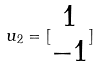<formula> <loc_0><loc_0><loc_500><loc_500>u _ { 2 } = [ \begin{matrix} 1 \\ - 1 \end{matrix} ]</formula> 